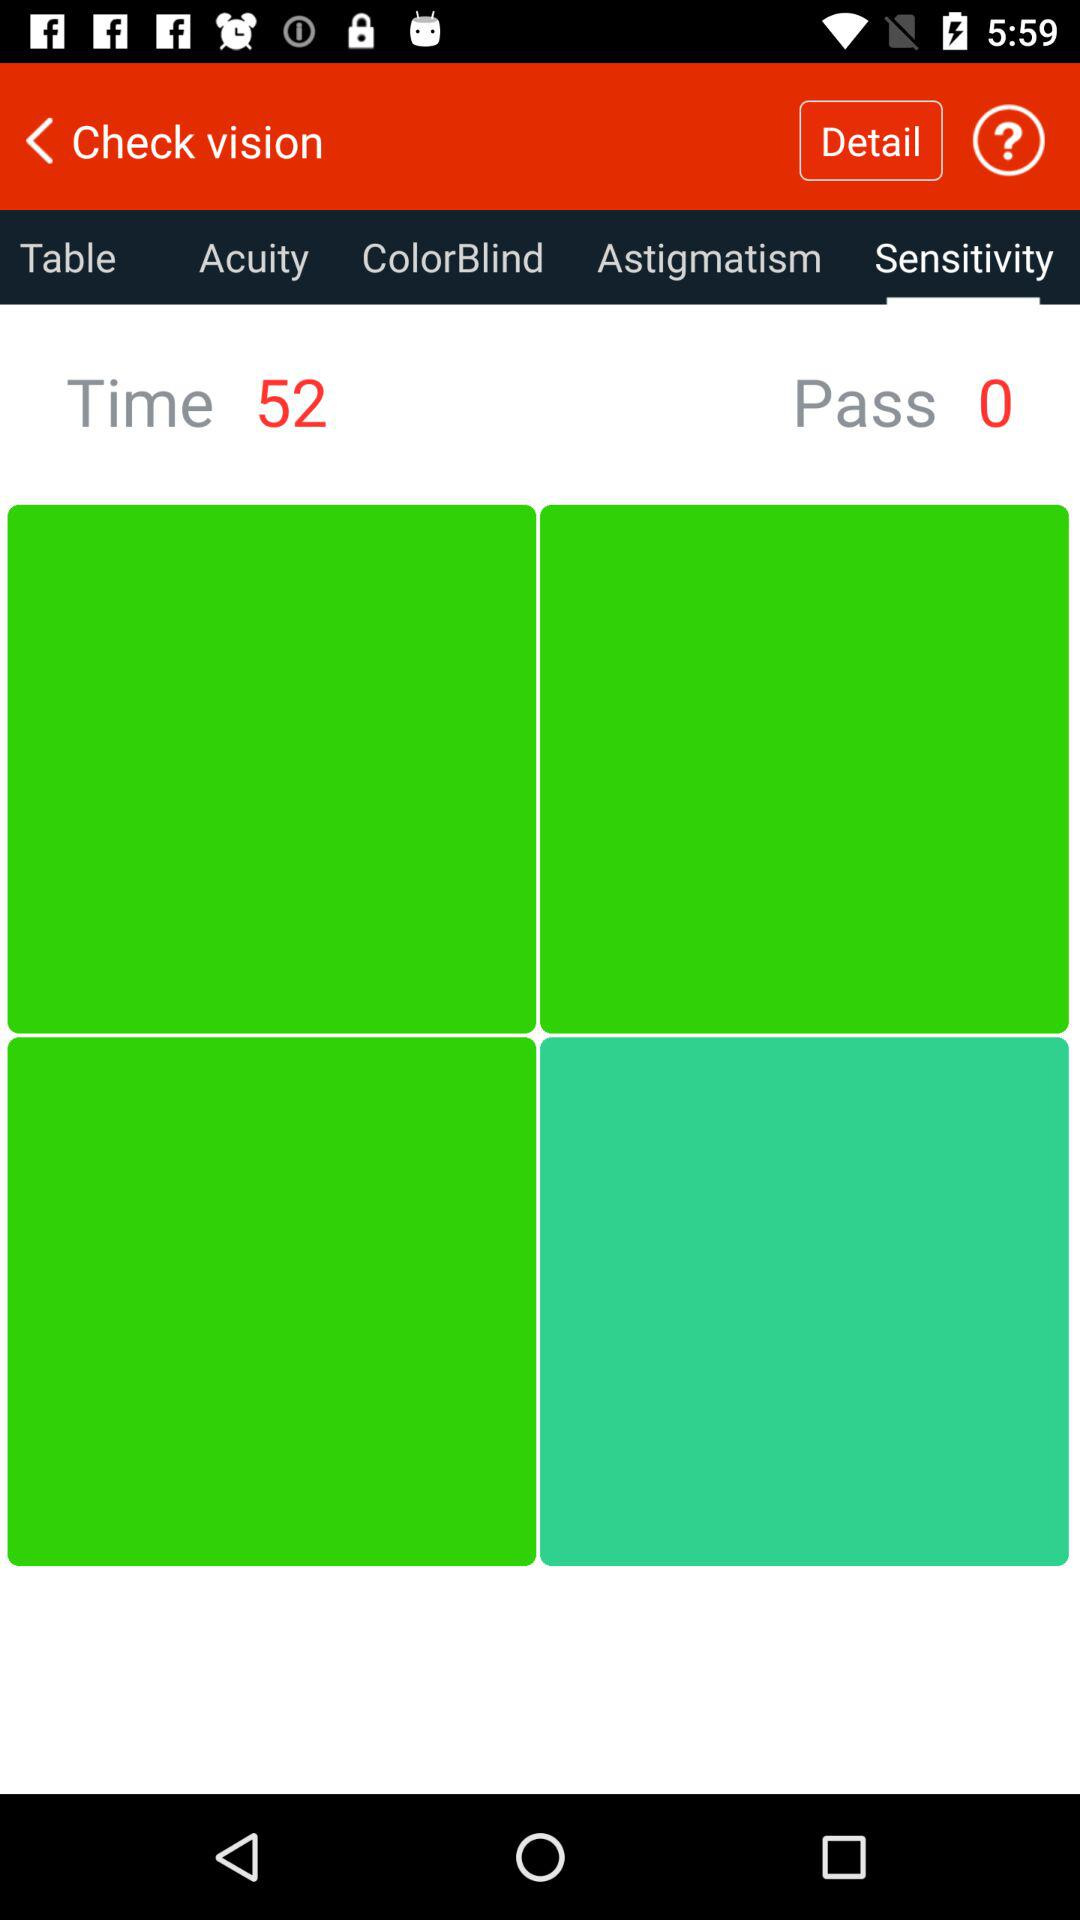Which tab is selected? The selected tab is "Sensitivity". 